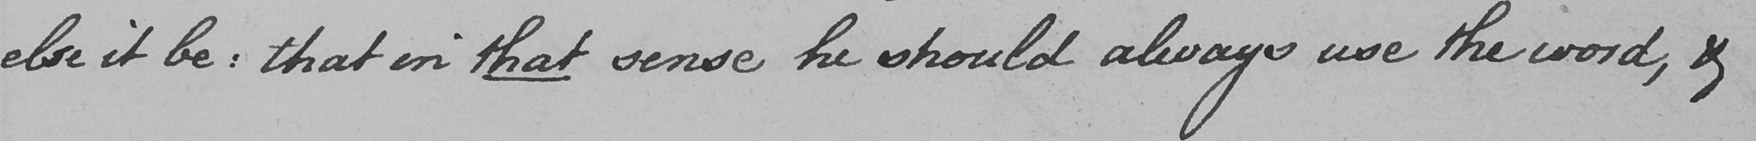What is written in this line of handwriting? else it be :  that in that sense he should always use the word , & 